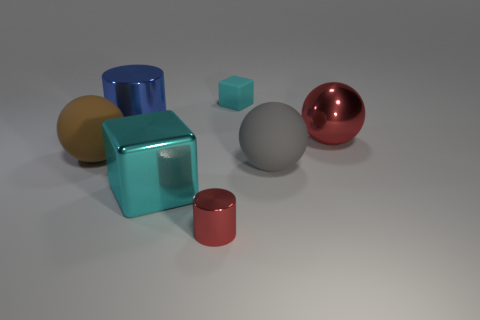What number of other objects are the same material as the blue thing?
Offer a very short reply. 3. How many things are either big cyan rubber things or tiny red shiny cylinders?
Keep it short and to the point. 1. Is the number of metal spheres in front of the brown rubber thing greater than the number of tiny cyan matte things in front of the big gray sphere?
Offer a very short reply. No. Is the color of the sphere in front of the large brown sphere the same as the rubber sphere that is to the left of the big cyan cube?
Offer a terse response. No. What size is the cylinder that is behind the matte ball that is to the right of the red object that is in front of the large metal cube?
Offer a very short reply. Large. There is a metallic object that is the same shape as the cyan rubber thing; what color is it?
Provide a succinct answer. Cyan. Is the number of large cubes that are right of the large metallic sphere greater than the number of large cyan matte objects?
Your answer should be very brief. No. Is the shape of the big cyan thing the same as the big brown thing left of the big metallic block?
Your response must be concise. No. Are there any other things that have the same size as the cyan metal object?
Keep it short and to the point. Yes. What size is the gray matte thing that is the same shape as the large brown thing?
Your answer should be very brief. Large. 